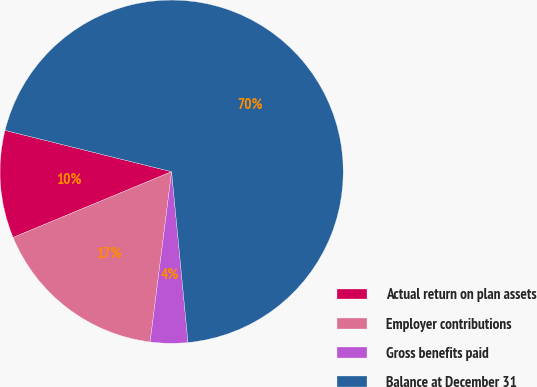Convert chart. <chart><loc_0><loc_0><loc_500><loc_500><pie_chart><fcel>Actual return on plan assets<fcel>Employer contributions<fcel>Gross benefits paid<fcel>Balance at December 31<nl><fcel>10.13%<fcel>16.74%<fcel>3.52%<fcel>69.6%<nl></chart> 